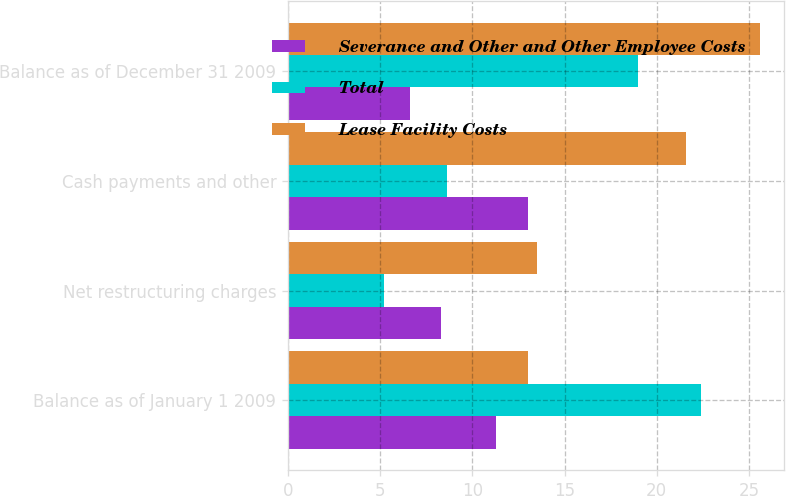<chart> <loc_0><loc_0><loc_500><loc_500><stacked_bar_chart><ecel><fcel>Balance as of January 1 2009<fcel>Net restructuring charges<fcel>Cash payments and other<fcel>Balance as of December 31 2009<nl><fcel>Severance and Other and Other Employee Costs<fcel>11.3<fcel>8.3<fcel>13<fcel>6.6<nl><fcel>Total<fcel>22.4<fcel>5.2<fcel>8.6<fcel>19<nl><fcel>Lease Facility Costs<fcel>13<fcel>13.5<fcel>21.6<fcel>25.6<nl></chart> 